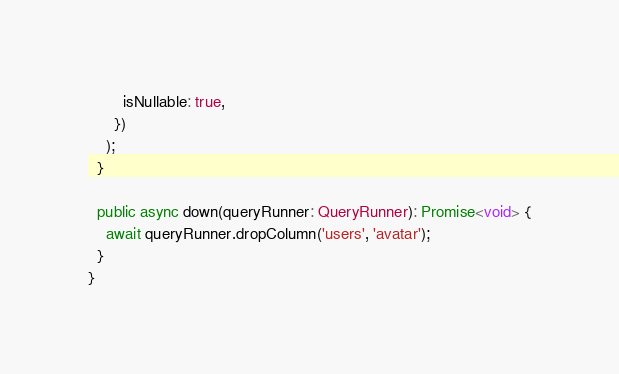Convert code to text. <code><loc_0><loc_0><loc_500><loc_500><_TypeScript_>        isNullable: true,
      })
    );
  }

  public async down(queryRunner: QueryRunner): Promise<void> {
    await queryRunner.dropColumn('users', 'avatar');
  }
}
</code> 